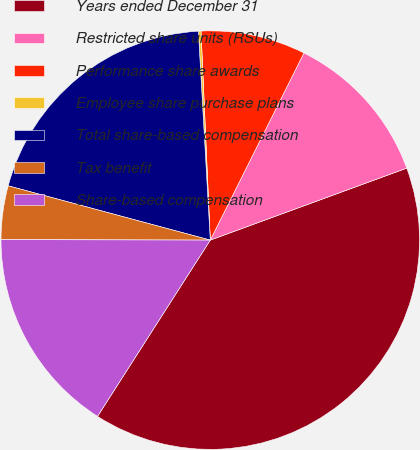Convert chart. <chart><loc_0><loc_0><loc_500><loc_500><pie_chart><fcel>Years ended December 31<fcel>Restricted share units (RSUs)<fcel>Performance share awards<fcel>Employee share purchase plans<fcel>Total share-based compensation<fcel>Tax benefit<fcel>Share-based compensation<nl><fcel>39.65%<fcel>12.03%<fcel>8.09%<fcel>0.2%<fcel>19.92%<fcel>4.14%<fcel>15.98%<nl></chart> 